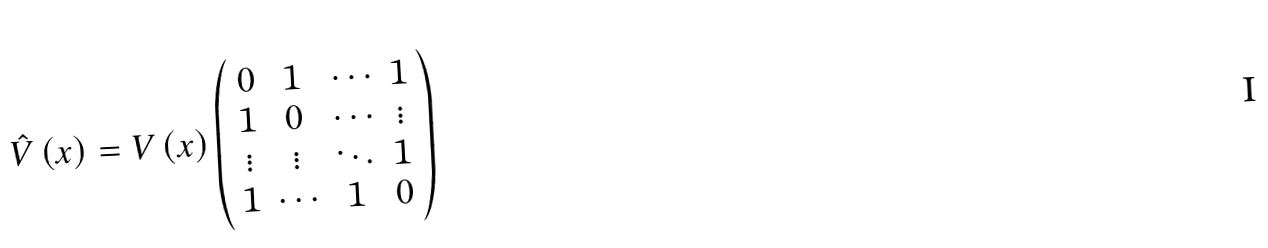Convert formula to latex. <formula><loc_0><loc_0><loc_500><loc_500>\hat { V } \left ( x \right ) = V \left ( x \right ) \left ( \begin{array} { c c c c } { 0 } & { 1 } & { \cdots } & { 1 } \\ { 1 } & { 0 } & { \cdots } & { \vdots } \\ { \vdots } & { \vdots } & { \ddots } & { 1 } \\ { 1 } & { \cdots } & { 1 } & { 0 } \end{array} \right )</formula> 